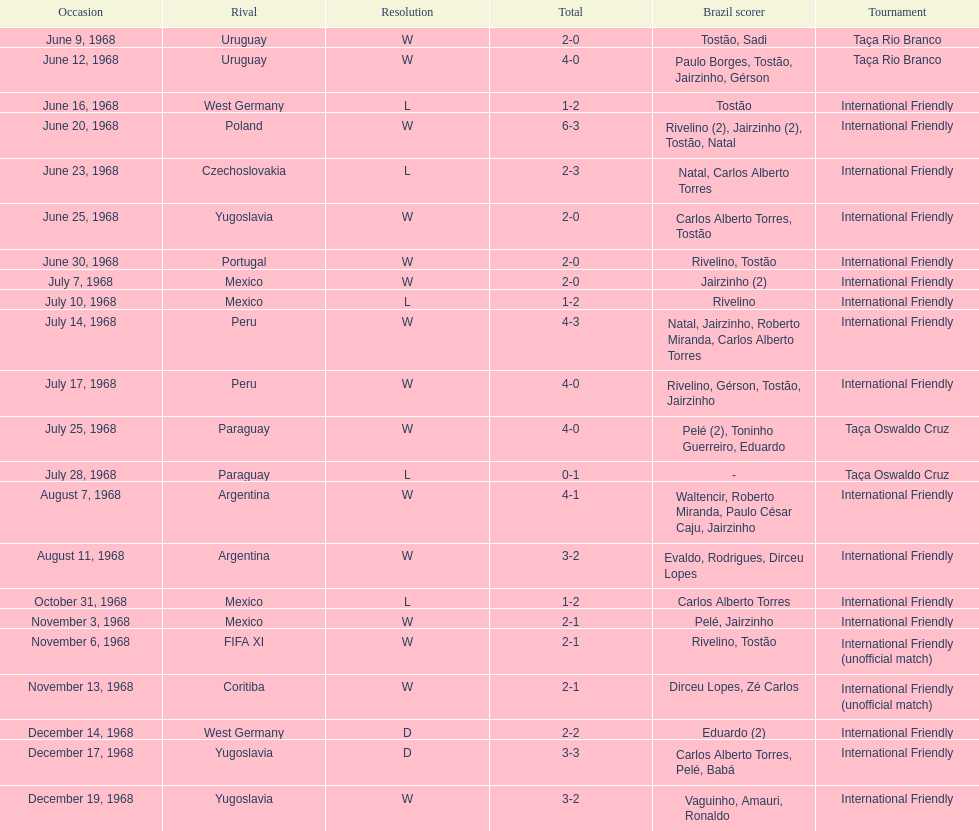Total number of wins 15. 